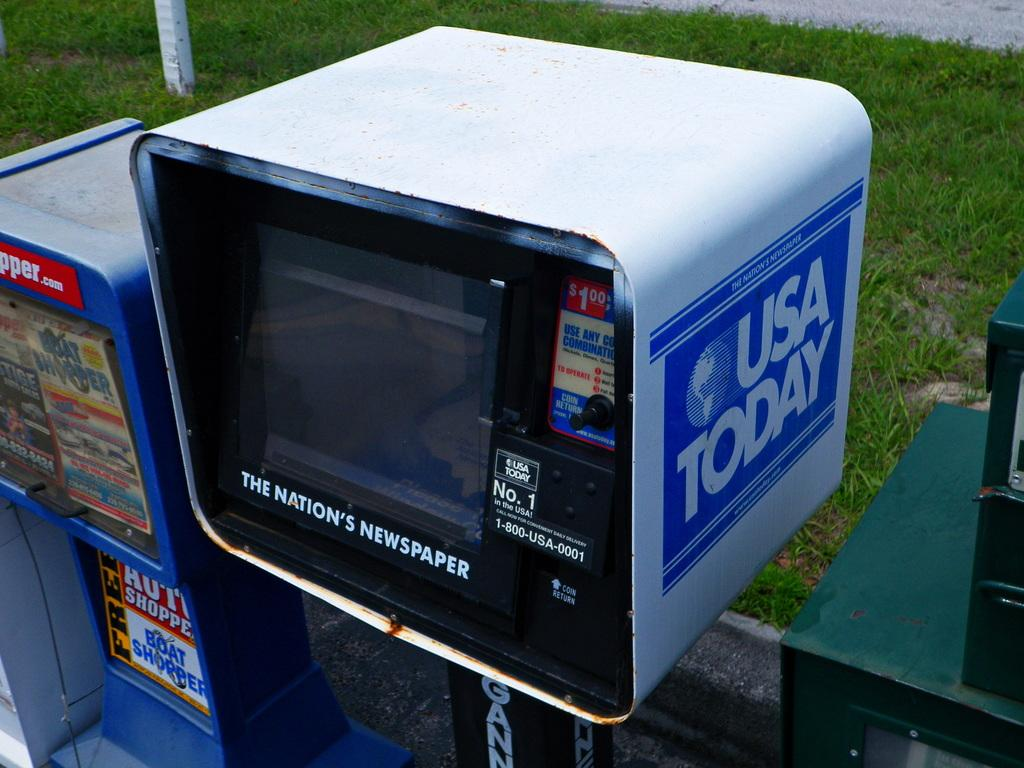What can be seen in the image? There are machines in the image. What distinguishes the machines in the image? The machines have a logo and text written on them. What can be seen in the background of the image? There is grass in the background of the image. Where is the grandmother sitting during recess in the image? There is no grandmother or recess present in the image; it features machines with a logo and text, and a grassy background. 